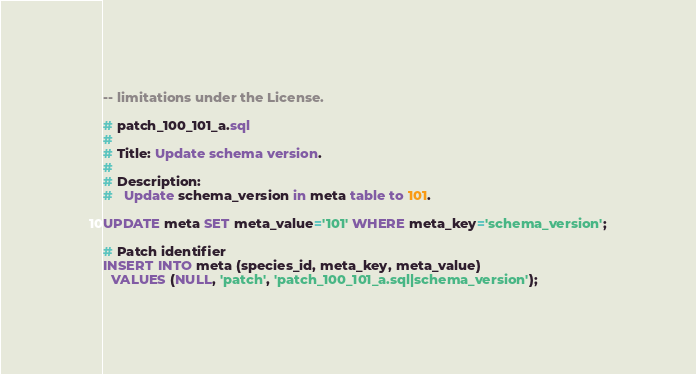Convert code to text. <code><loc_0><loc_0><loc_500><loc_500><_SQL_>-- limitations under the License.

# patch_100_101_a.sql
#
# Title: Update schema version.
#
# Description:
#   Update schema_version in meta table to 101.

UPDATE meta SET meta_value='101' WHERE meta_key='schema_version';

# Patch identifier
INSERT INTO meta (species_id, meta_key, meta_value)
  VALUES (NULL, 'patch', 'patch_100_101_a.sql|schema_version');
</code> 